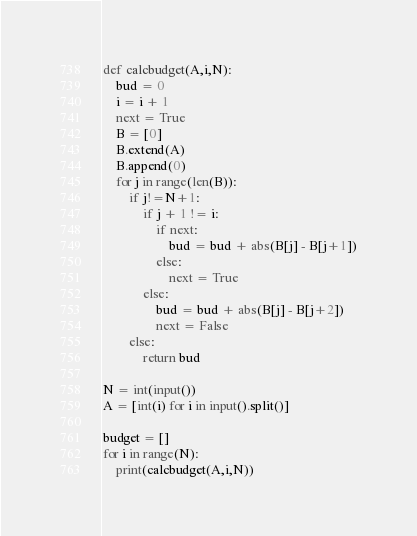<code> <loc_0><loc_0><loc_500><loc_500><_Python_>def calcbudget(A,i,N):
    bud = 0
    i = i + 1
    next = True
    B = [0]
    B.extend(A)
    B.append(0)
    for j in range(len(B)):
        if j!=N+1:
            if j + 1 != i:
                if next:
                    bud = bud + abs(B[j] - B[j+1])
                else:
                    next = True
            else:
                bud = bud + abs(B[j] - B[j+2])
                next = False
        else:
            return bud

N = int(input())
A = [int(i) for i in input().split()]

budget = []
for i in range(N):
    print(calcbudget(A,i,N))
</code> 